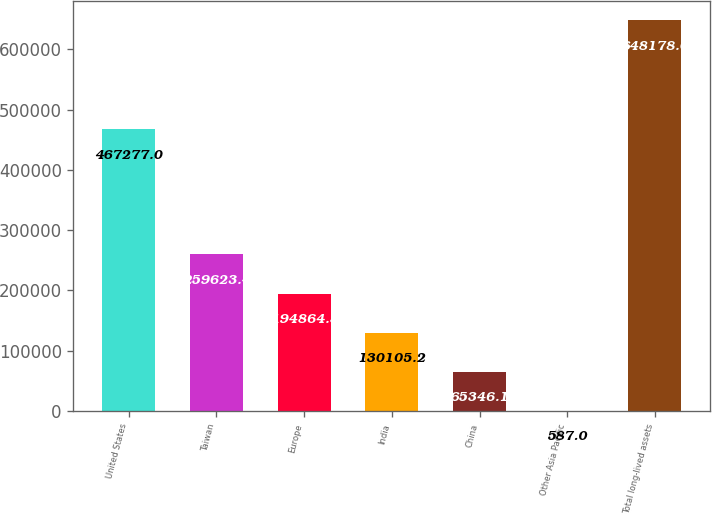<chart> <loc_0><loc_0><loc_500><loc_500><bar_chart><fcel>United States<fcel>Taiwan<fcel>Europe<fcel>India<fcel>China<fcel>Other Asia Pacific<fcel>Total long-lived assets<nl><fcel>467277<fcel>259623<fcel>194864<fcel>130105<fcel>65346.1<fcel>587<fcel>648178<nl></chart> 